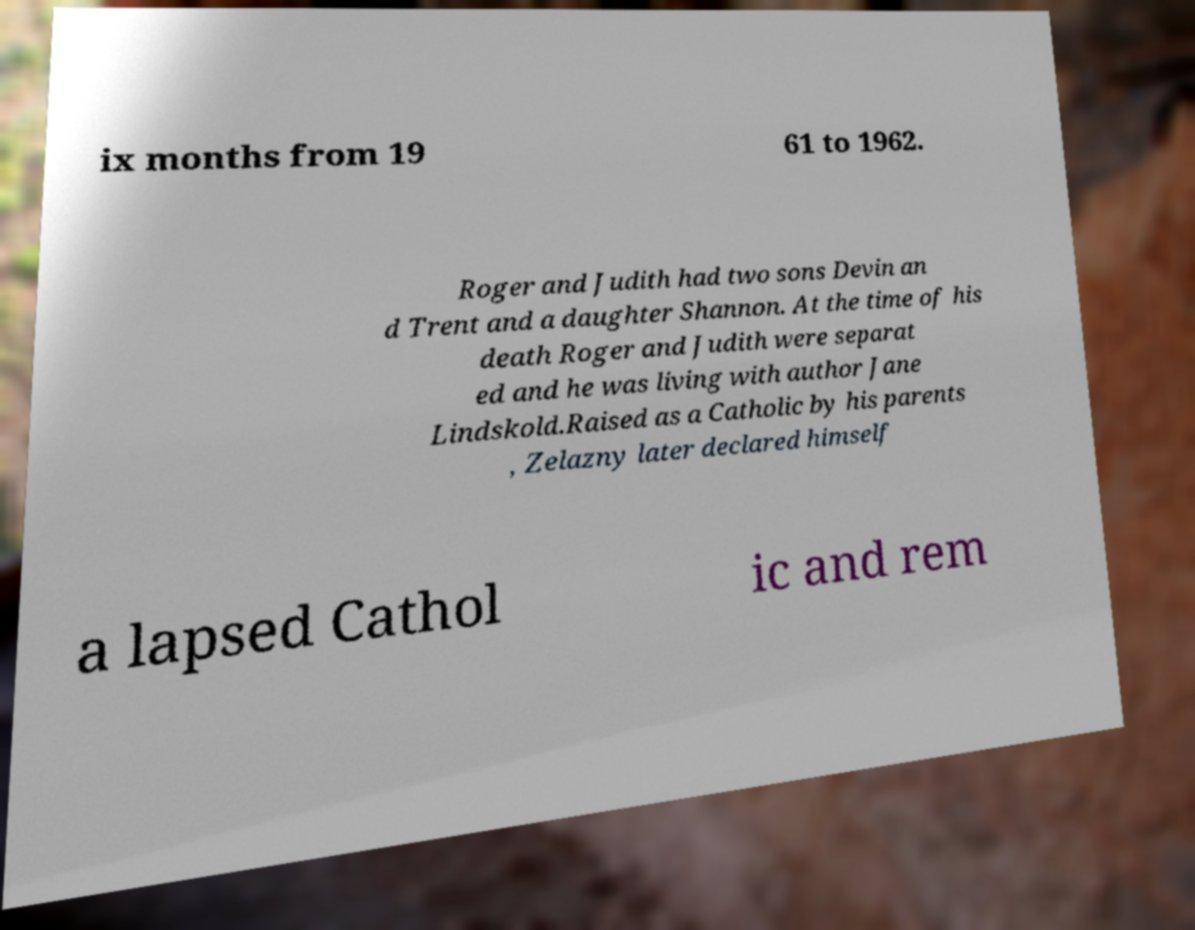I need the written content from this picture converted into text. Can you do that? ix months from 19 61 to 1962. Roger and Judith had two sons Devin an d Trent and a daughter Shannon. At the time of his death Roger and Judith were separat ed and he was living with author Jane Lindskold.Raised as a Catholic by his parents , Zelazny later declared himself a lapsed Cathol ic and rem 